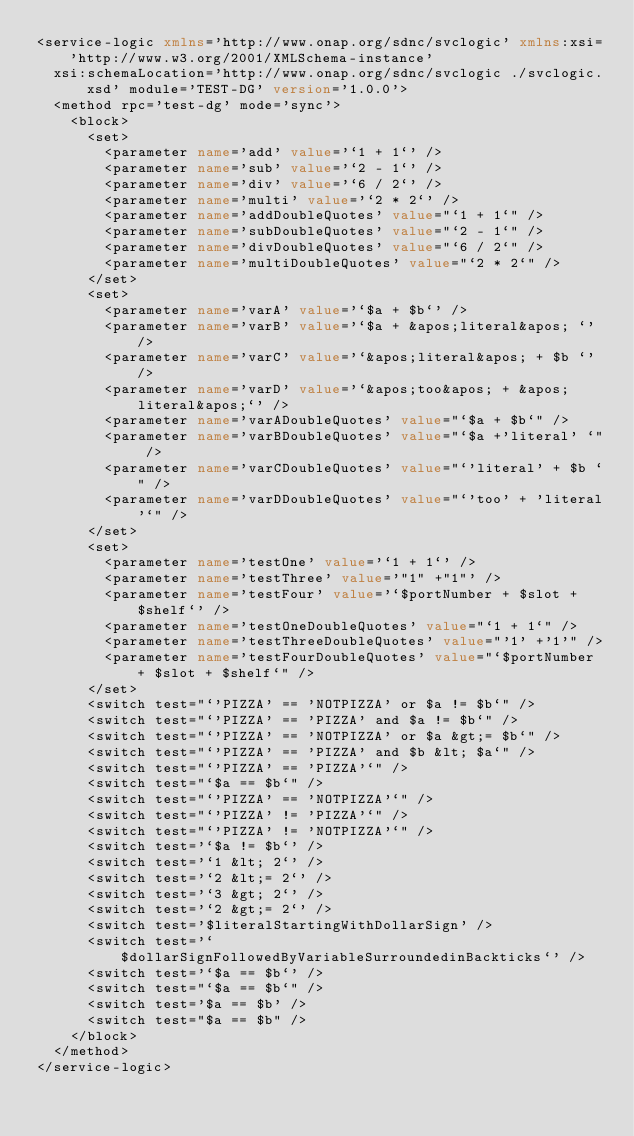<code> <loc_0><loc_0><loc_500><loc_500><_XML_><service-logic xmlns='http://www.onap.org/sdnc/svclogic' xmlns:xsi='http://www.w3.org/2001/XMLSchema-instance'
	xsi:schemaLocation='http://www.onap.org/sdnc/svclogic ./svclogic.xsd' module='TEST-DG' version='1.0.0'>
	<method rpc='test-dg' mode='sync'>
		<block>
			<set>
				<parameter name='add' value='`1 + 1`' />
				<parameter name='sub' value='`2 - 1`' />
				<parameter name='div' value='`6 / 2`' />
				<parameter name='multi' value='`2 * 2`' />
				<parameter name='addDoubleQuotes' value="`1 + 1`" />
				<parameter name='subDoubleQuotes' value="`2 - 1`" />
				<parameter name='divDoubleQuotes' value="`6 / 2`" />
				<parameter name='multiDoubleQuotes' value="`2 * 2`" />
			</set>
			<set>
				<parameter name='varA' value='`$a + $b`' />
				<parameter name='varB' value='`$a + &apos;literal&apos; `' />
				<parameter name='varC' value='`&apos;literal&apos; + $b `' />
				<parameter name='varD' value='`&apos;too&apos; + &apos;literal&apos;`' />
				<parameter name='varADoubleQuotes' value="`$a + $b`" />
				<parameter name='varBDoubleQuotes' value="`$a +'literal' `" />
				<parameter name='varCDoubleQuotes' value="`'literal' + $b `" />
				<parameter name='varDDoubleQuotes' value="`'too' + 'literal'`" />
			</set>
			<set>
				<parameter name='testOne' value='`1 + 1`' />
				<parameter name='testThree' value='"1" +"1"' />
				<parameter name='testFour' value='`$portNumber + $slot + $shelf`' />
				<parameter name='testOneDoubleQuotes' value="`1 + 1`" />
				<parameter name='testThreeDoubleQuotes' value="'1' +'1'" />
				<parameter name='testFourDoubleQuotes' value="`$portNumber + $slot + $shelf`" />
			</set>
			<switch test="`'PIZZA' == 'NOTPIZZA' or $a != $b`" />
			<switch test="`'PIZZA' == 'PIZZA' and $a != $b`" />
			<switch test="`'PIZZA' == 'NOTPIZZA' or $a &gt;= $b`" />
			<switch test="`'PIZZA' == 'PIZZA' and $b &lt; $a`" />
			<switch test="`'PIZZA' == 'PIZZA'`" />
			<switch test="`$a == $b`" />
			<switch test="`'PIZZA' == 'NOTPIZZA'`" />
			<switch test="`'PIZZA' != 'PIZZA'`" />
			<switch test="`'PIZZA' != 'NOTPIZZA'`" />
			<switch test='`$a != $b`' />
			<switch test='`1 &lt; 2`' />
			<switch test='`2 &lt;= 2`' />
			<switch test='`3 &gt; 2`' />
			<switch test='`2 &gt;= 2`' />
			<switch test='$literalStartingWithDollarSign' />
			<switch test='`$dollarSignFollowedByVariableSurroundedinBackticks`' />
			<switch test='`$a == $b`' />
			<switch test="`$a == $b`" />
			<switch test='$a == $b' />
			<switch test="$a == $b" />
		</block>
	</method>
</service-logic></code> 